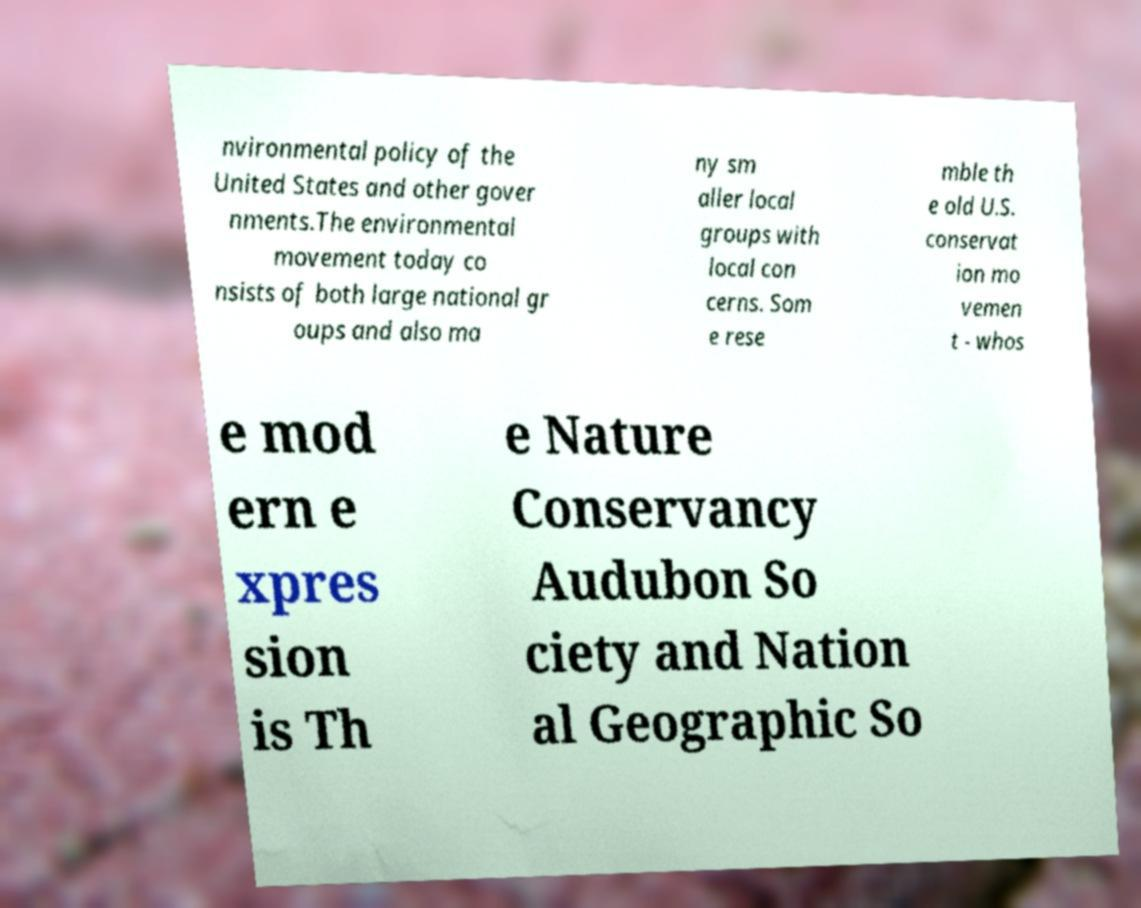There's text embedded in this image that I need extracted. Can you transcribe it verbatim? nvironmental policy of the United States and other gover nments.The environmental movement today co nsists of both large national gr oups and also ma ny sm aller local groups with local con cerns. Som e rese mble th e old U.S. conservat ion mo vemen t - whos e mod ern e xpres sion is Th e Nature Conservancy Audubon So ciety and Nation al Geographic So 